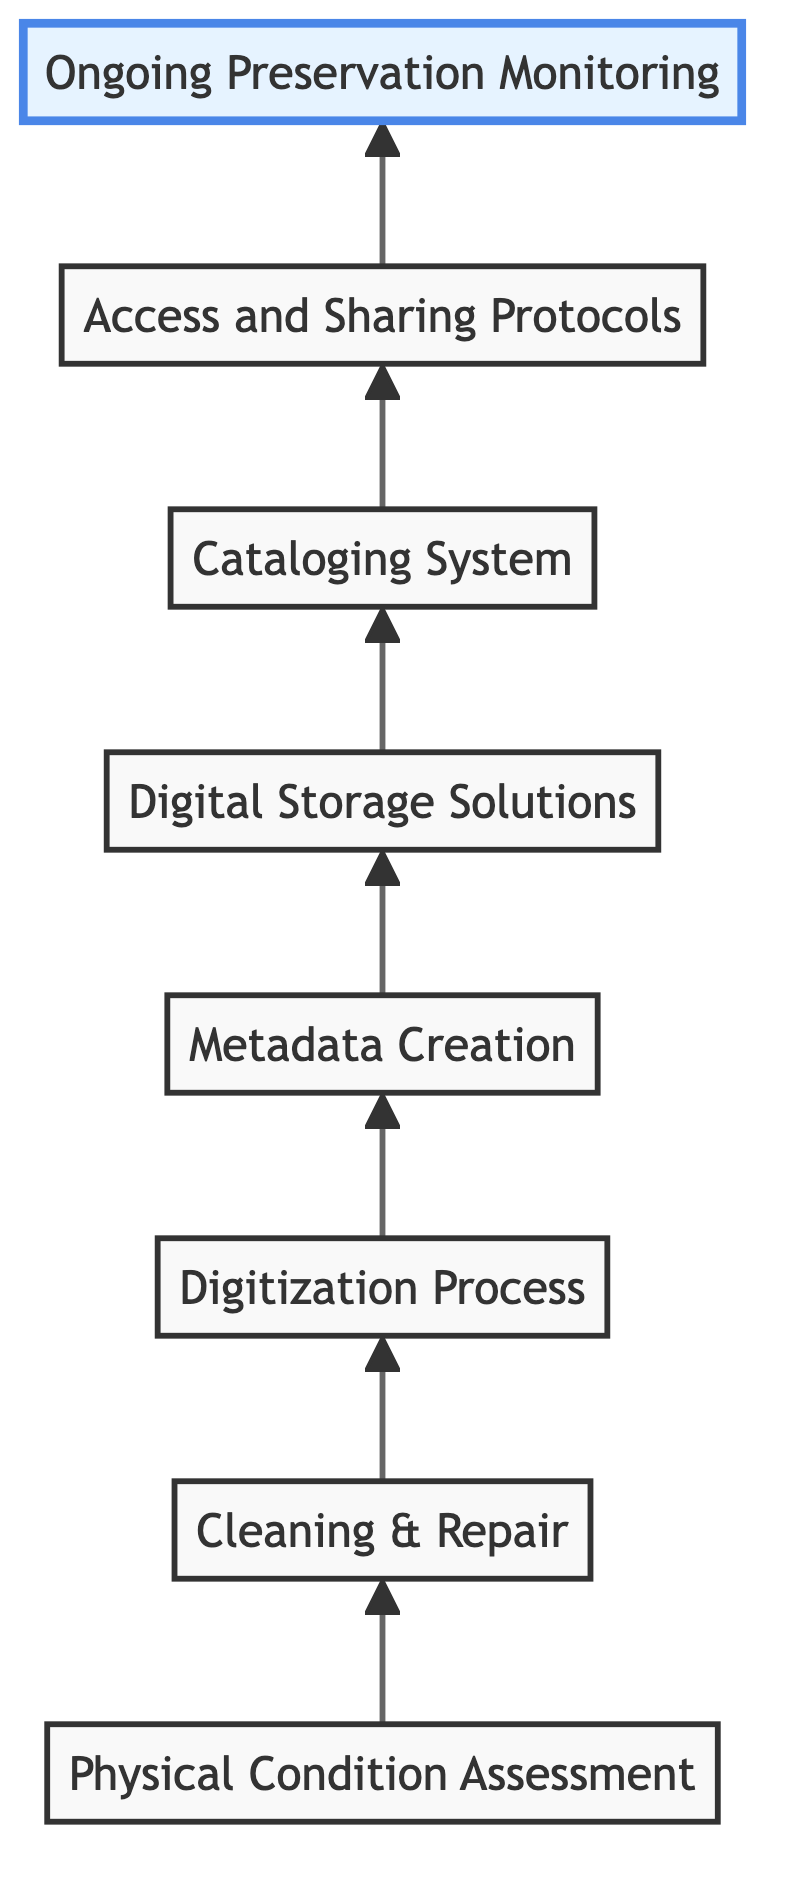What is the first step in the workflow? The first step in the workflow is "Physical Condition Assessment." This is the starting point before any cleaning or repair can be considered.
Answer: Physical Condition Assessment How many total steps are there in the archiving workflow? By counting each distinct step in the diagram, we identify a total of 8 steps, from "Physical Condition Assessment" through to "Ongoing Preservation Monitoring."
Answer: 8 What step follows "Cleaning & Repair"? The step that follows "Cleaning & Repair" is "Digitization Process." This indicates that after repairing, the next action is to digitize the text.
Answer: Digitization Process What is established after "Access and Sharing Protocols"? The diagram does not indicate any step following "Access and Sharing Protocols," which is the last step before "Ongoing Preservation Monitoring," marking the end of this workflow.
Answer: None Which step involves creating detailed metadata? The step that involves creating detailed metadata is "Metadata Creation." This happens after the digitization of the text, focusing on organizing information about the text.
Answer: Metadata Creation What is the role of "Digital Storage Solutions" in the workflow? "Digital Storage Solutions" serves as a secure space for storing the digitized texts, ensuring they are organized and preserved after digitization and metadata creation.
Answer: Secure storage How does "Cleaning & Repair" relate to "Digitization Process"? "Cleaning & Repair" precedes "Digitization Process," indicating that texts must be prepared by cleaning and repairing before being scanned or digitized.
Answer: Precedes In which step is ongoing monitoring implemented? Ongoing monitoring is implemented in the last step, "Ongoing Preservation Monitoring." This step is designed to ensure the continued assessment and management of the collections.
Answer: Ongoing Preservation Monitoring What connects the "Cataloging System" to "Access and Sharing Protocols"? The connection between "Cataloging System" and "Access and Sharing Protocols" shows that establishing a catalog system facilitates better public access and sharing of the digitized works.
Answer: Facilitation of access 